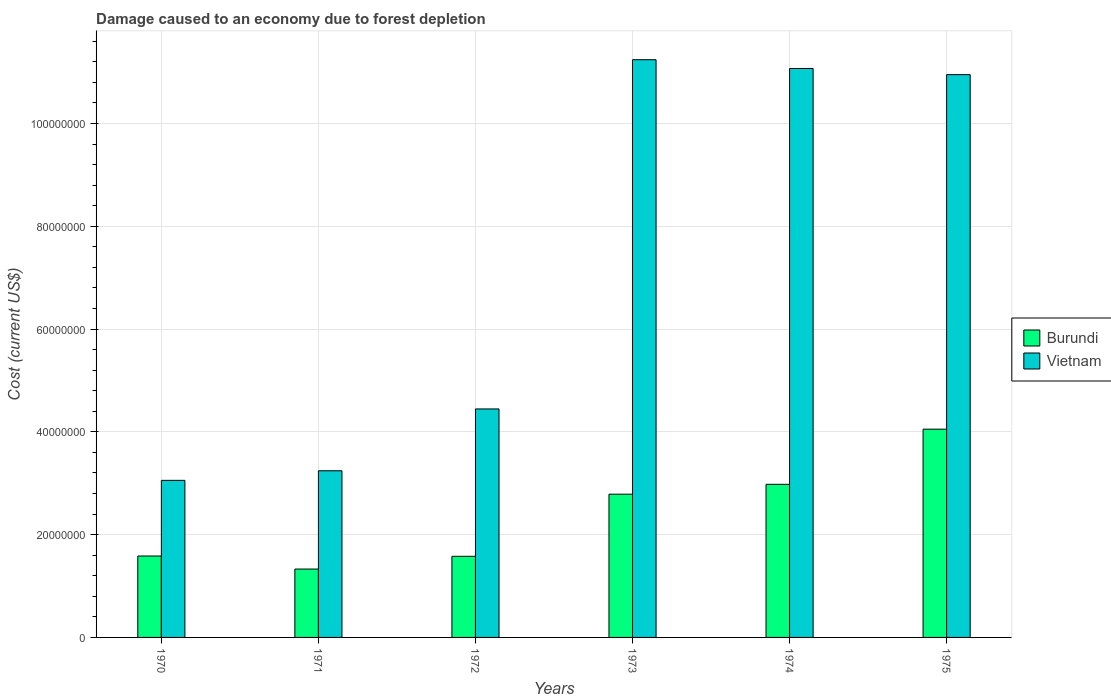How many groups of bars are there?
Provide a short and direct response. 6. Are the number of bars per tick equal to the number of legend labels?
Provide a short and direct response. Yes. How many bars are there on the 5th tick from the left?
Your answer should be compact. 2. What is the label of the 4th group of bars from the left?
Offer a terse response. 1973. What is the cost of damage caused due to forest depletion in Burundi in 1972?
Your answer should be very brief. 1.58e+07. Across all years, what is the maximum cost of damage caused due to forest depletion in Vietnam?
Your answer should be compact. 1.12e+08. Across all years, what is the minimum cost of damage caused due to forest depletion in Burundi?
Give a very brief answer. 1.33e+07. In which year was the cost of damage caused due to forest depletion in Burundi maximum?
Give a very brief answer. 1975. What is the total cost of damage caused due to forest depletion in Burundi in the graph?
Keep it short and to the point. 1.43e+08. What is the difference between the cost of damage caused due to forest depletion in Vietnam in 1970 and that in 1975?
Offer a terse response. -7.89e+07. What is the difference between the cost of damage caused due to forest depletion in Burundi in 1975 and the cost of damage caused due to forest depletion in Vietnam in 1972?
Your answer should be very brief. -3.94e+06. What is the average cost of damage caused due to forest depletion in Vietnam per year?
Your response must be concise. 7.33e+07. In the year 1970, what is the difference between the cost of damage caused due to forest depletion in Vietnam and cost of damage caused due to forest depletion in Burundi?
Offer a very short reply. 1.47e+07. In how many years, is the cost of damage caused due to forest depletion in Burundi greater than 52000000 US$?
Provide a short and direct response. 0. What is the ratio of the cost of damage caused due to forest depletion in Burundi in 1970 to that in 1975?
Your answer should be compact. 0.39. Is the cost of damage caused due to forest depletion in Vietnam in 1973 less than that in 1974?
Your response must be concise. No. What is the difference between the highest and the second highest cost of damage caused due to forest depletion in Burundi?
Provide a short and direct response. 1.07e+07. What is the difference between the highest and the lowest cost of damage caused due to forest depletion in Burundi?
Make the answer very short. 2.72e+07. Is the sum of the cost of damage caused due to forest depletion in Burundi in 1973 and 1974 greater than the maximum cost of damage caused due to forest depletion in Vietnam across all years?
Provide a short and direct response. No. What does the 2nd bar from the left in 1973 represents?
Provide a succinct answer. Vietnam. What does the 2nd bar from the right in 1972 represents?
Keep it short and to the point. Burundi. How many bars are there?
Your answer should be compact. 12. Are all the bars in the graph horizontal?
Provide a short and direct response. No. What is the difference between two consecutive major ticks on the Y-axis?
Provide a short and direct response. 2.00e+07. Does the graph contain any zero values?
Your response must be concise. No. How many legend labels are there?
Provide a succinct answer. 2. How are the legend labels stacked?
Ensure brevity in your answer.  Vertical. What is the title of the graph?
Ensure brevity in your answer.  Damage caused to an economy due to forest depletion. What is the label or title of the Y-axis?
Provide a short and direct response. Cost (current US$). What is the Cost (current US$) in Burundi in 1970?
Ensure brevity in your answer.  1.58e+07. What is the Cost (current US$) of Vietnam in 1970?
Offer a very short reply. 3.06e+07. What is the Cost (current US$) of Burundi in 1971?
Offer a terse response. 1.33e+07. What is the Cost (current US$) in Vietnam in 1971?
Ensure brevity in your answer.  3.24e+07. What is the Cost (current US$) of Burundi in 1972?
Offer a very short reply. 1.58e+07. What is the Cost (current US$) in Vietnam in 1972?
Give a very brief answer. 4.45e+07. What is the Cost (current US$) of Burundi in 1973?
Make the answer very short. 2.79e+07. What is the Cost (current US$) in Vietnam in 1973?
Your answer should be compact. 1.12e+08. What is the Cost (current US$) of Burundi in 1974?
Ensure brevity in your answer.  2.98e+07. What is the Cost (current US$) in Vietnam in 1974?
Your response must be concise. 1.11e+08. What is the Cost (current US$) in Burundi in 1975?
Your answer should be very brief. 4.05e+07. What is the Cost (current US$) in Vietnam in 1975?
Give a very brief answer. 1.10e+08. Across all years, what is the maximum Cost (current US$) in Burundi?
Your answer should be compact. 4.05e+07. Across all years, what is the maximum Cost (current US$) in Vietnam?
Your answer should be compact. 1.12e+08. Across all years, what is the minimum Cost (current US$) of Burundi?
Provide a succinct answer. 1.33e+07. Across all years, what is the minimum Cost (current US$) of Vietnam?
Provide a short and direct response. 3.06e+07. What is the total Cost (current US$) of Burundi in the graph?
Give a very brief answer. 1.43e+08. What is the total Cost (current US$) of Vietnam in the graph?
Make the answer very short. 4.40e+08. What is the difference between the Cost (current US$) in Burundi in 1970 and that in 1971?
Make the answer very short. 2.54e+06. What is the difference between the Cost (current US$) of Vietnam in 1970 and that in 1971?
Provide a succinct answer. -1.87e+06. What is the difference between the Cost (current US$) of Burundi in 1970 and that in 1972?
Make the answer very short. 5.64e+04. What is the difference between the Cost (current US$) of Vietnam in 1970 and that in 1972?
Offer a very short reply. -1.39e+07. What is the difference between the Cost (current US$) of Burundi in 1970 and that in 1973?
Provide a succinct answer. -1.20e+07. What is the difference between the Cost (current US$) in Vietnam in 1970 and that in 1973?
Ensure brevity in your answer.  -8.18e+07. What is the difference between the Cost (current US$) of Burundi in 1970 and that in 1974?
Provide a succinct answer. -1.39e+07. What is the difference between the Cost (current US$) in Vietnam in 1970 and that in 1974?
Keep it short and to the point. -8.01e+07. What is the difference between the Cost (current US$) of Burundi in 1970 and that in 1975?
Your response must be concise. -2.47e+07. What is the difference between the Cost (current US$) in Vietnam in 1970 and that in 1975?
Your answer should be compact. -7.89e+07. What is the difference between the Cost (current US$) in Burundi in 1971 and that in 1972?
Ensure brevity in your answer.  -2.48e+06. What is the difference between the Cost (current US$) of Vietnam in 1971 and that in 1972?
Your answer should be compact. -1.20e+07. What is the difference between the Cost (current US$) of Burundi in 1971 and that in 1973?
Make the answer very short. -1.46e+07. What is the difference between the Cost (current US$) of Vietnam in 1971 and that in 1973?
Your answer should be compact. -8.00e+07. What is the difference between the Cost (current US$) of Burundi in 1971 and that in 1974?
Offer a very short reply. -1.65e+07. What is the difference between the Cost (current US$) in Vietnam in 1971 and that in 1974?
Your answer should be compact. -7.83e+07. What is the difference between the Cost (current US$) in Burundi in 1971 and that in 1975?
Keep it short and to the point. -2.72e+07. What is the difference between the Cost (current US$) of Vietnam in 1971 and that in 1975?
Offer a terse response. -7.71e+07. What is the difference between the Cost (current US$) of Burundi in 1972 and that in 1973?
Make the answer very short. -1.21e+07. What is the difference between the Cost (current US$) in Vietnam in 1972 and that in 1973?
Make the answer very short. -6.79e+07. What is the difference between the Cost (current US$) in Burundi in 1972 and that in 1974?
Offer a very short reply. -1.40e+07. What is the difference between the Cost (current US$) of Vietnam in 1972 and that in 1974?
Give a very brief answer. -6.62e+07. What is the difference between the Cost (current US$) in Burundi in 1972 and that in 1975?
Make the answer very short. -2.47e+07. What is the difference between the Cost (current US$) in Vietnam in 1972 and that in 1975?
Keep it short and to the point. -6.50e+07. What is the difference between the Cost (current US$) of Burundi in 1973 and that in 1974?
Ensure brevity in your answer.  -1.92e+06. What is the difference between the Cost (current US$) in Vietnam in 1973 and that in 1974?
Make the answer very short. 1.70e+06. What is the difference between the Cost (current US$) in Burundi in 1973 and that in 1975?
Your answer should be compact. -1.27e+07. What is the difference between the Cost (current US$) of Vietnam in 1973 and that in 1975?
Your answer should be very brief. 2.90e+06. What is the difference between the Cost (current US$) of Burundi in 1974 and that in 1975?
Provide a succinct answer. -1.07e+07. What is the difference between the Cost (current US$) in Vietnam in 1974 and that in 1975?
Your response must be concise. 1.20e+06. What is the difference between the Cost (current US$) of Burundi in 1970 and the Cost (current US$) of Vietnam in 1971?
Ensure brevity in your answer.  -1.66e+07. What is the difference between the Cost (current US$) of Burundi in 1970 and the Cost (current US$) of Vietnam in 1972?
Give a very brief answer. -2.86e+07. What is the difference between the Cost (current US$) in Burundi in 1970 and the Cost (current US$) in Vietnam in 1973?
Provide a succinct answer. -9.66e+07. What is the difference between the Cost (current US$) in Burundi in 1970 and the Cost (current US$) in Vietnam in 1974?
Keep it short and to the point. -9.49e+07. What is the difference between the Cost (current US$) in Burundi in 1970 and the Cost (current US$) in Vietnam in 1975?
Your answer should be very brief. -9.37e+07. What is the difference between the Cost (current US$) in Burundi in 1971 and the Cost (current US$) in Vietnam in 1972?
Provide a succinct answer. -3.12e+07. What is the difference between the Cost (current US$) in Burundi in 1971 and the Cost (current US$) in Vietnam in 1973?
Provide a succinct answer. -9.91e+07. What is the difference between the Cost (current US$) of Burundi in 1971 and the Cost (current US$) of Vietnam in 1974?
Offer a very short reply. -9.74e+07. What is the difference between the Cost (current US$) of Burundi in 1971 and the Cost (current US$) of Vietnam in 1975?
Keep it short and to the point. -9.62e+07. What is the difference between the Cost (current US$) of Burundi in 1972 and the Cost (current US$) of Vietnam in 1973?
Offer a terse response. -9.66e+07. What is the difference between the Cost (current US$) in Burundi in 1972 and the Cost (current US$) in Vietnam in 1974?
Provide a succinct answer. -9.49e+07. What is the difference between the Cost (current US$) in Burundi in 1972 and the Cost (current US$) in Vietnam in 1975?
Your answer should be compact. -9.37e+07. What is the difference between the Cost (current US$) of Burundi in 1973 and the Cost (current US$) of Vietnam in 1974?
Make the answer very short. -8.28e+07. What is the difference between the Cost (current US$) in Burundi in 1973 and the Cost (current US$) in Vietnam in 1975?
Offer a very short reply. -8.16e+07. What is the difference between the Cost (current US$) in Burundi in 1974 and the Cost (current US$) in Vietnam in 1975?
Ensure brevity in your answer.  -7.97e+07. What is the average Cost (current US$) of Burundi per year?
Keep it short and to the point. 2.39e+07. What is the average Cost (current US$) of Vietnam per year?
Offer a very short reply. 7.33e+07. In the year 1970, what is the difference between the Cost (current US$) in Burundi and Cost (current US$) in Vietnam?
Ensure brevity in your answer.  -1.47e+07. In the year 1971, what is the difference between the Cost (current US$) of Burundi and Cost (current US$) of Vietnam?
Provide a succinct answer. -1.91e+07. In the year 1972, what is the difference between the Cost (current US$) of Burundi and Cost (current US$) of Vietnam?
Provide a succinct answer. -2.87e+07. In the year 1973, what is the difference between the Cost (current US$) in Burundi and Cost (current US$) in Vietnam?
Ensure brevity in your answer.  -8.45e+07. In the year 1974, what is the difference between the Cost (current US$) in Burundi and Cost (current US$) in Vietnam?
Provide a short and direct response. -8.09e+07. In the year 1975, what is the difference between the Cost (current US$) of Burundi and Cost (current US$) of Vietnam?
Offer a terse response. -6.90e+07. What is the ratio of the Cost (current US$) of Burundi in 1970 to that in 1971?
Your answer should be very brief. 1.19. What is the ratio of the Cost (current US$) of Vietnam in 1970 to that in 1971?
Make the answer very short. 0.94. What is the ratio of the Cost (current US$) in Vietnam in 1970 to that in 1972?
Give a very brief answer. 0.69. What is the ratio of the Cost (current US$) of Burundi in 1970 to that in 1973?
Offer a very short reply. 0.57. What is the ratio of the Cost (current US$) in Vietnam in 1970 to that in 1973?
Your response must be concise. 0.27. What is the ratio of the Cost (current US$) of Burundi in 1970 to that in 1974?
Your response must be concise. 0.53. What is the ratio of the Cost (current US$) of Vietnam in 1970 to that in 1974?
Your response must be concise. 0.28. What is the ratio of the Cost (current US$) in Burundi in 1970 to that in 1975?
Your answer should be compact. 0.39. What is the ratio of the Cost (current US$) of Vietnam in 1970 to that in 1975?
Provide a succinct answer. 0.28. What is the ratio of the Cost (current US$) in Burundi in 1971 to that in 1972?
Ensure brevity in your answer.  0.84. What is the ratio of the Cost (current US$) of Vietnam in 1971 to that in 1972?
Ensure brevity in your answer.  0.73. What is the ratio of the Cost (current US$) in Burundi in 1971 to that in 1973?
Ensure brevity in your answer.  0.48. What is the ratio of the Cost (current US$) in Vietnam in 1971 to that in 1973?
Your response must be concise. 0.29. What is the ratio of the Cost (current US$) in Burundi in 1971 to that in 1974?
Offer a very short reply. 0.45. What is the ratio of the Cost (current US$) in Vietnam in 1971 to that in 1974?
Your answer should be compact. 0.29. What is the ratio of the Cost (current US$) of Burundi in 1971 to that in 1975?
Your response must be concise. 0.33. What is the ratio of the Cost (current US$) in Vietnam in 1971 to that in 1975?
Offer a very short reply. 0.3. What is the ratio of the Cost (current US$) in Burundi in 1972 to that in 1973?
Offer a terse response. 0.57. What is the ratio of the Cost (current US$) in Vietnam in 1972 to that in 1973?
Keep it short and to the point. 0.4. What is the ratio of the Cost (current US$) in Burundi in 1972 to that in 1974?
Keep it short and to the point. 0.53. What is the ratio of the Cost (current US$) of Vietnam in 1972 to that in 1974?
Provide a succinct answer. 0.4. What is the ratio of the Cost (current US$) in Burundi in 1972 to that in 1975?
Offer a terse response. 0.39. What is the ratio of the Cost (current US$) of Vietnam in 1972 to that in 1975?
Keep it short and to the point. 0.41. What is the ratio of the Cost (current US$) of Burundi in 1973 to that in 1974?
Your answer should be compact. 0.94. What is the ratio of the Cost (current US$) in Vietnam in 1973 to that in 1974?
Provide a succinct answer. 1.02. What is the ratio of the Cost (current US$) in Burundi in 1973 to that in 1975?
Make the answer very short. 0.69. What is the ratio of the Cost (current US$) of Vietnam in 1973 to that in 1975?
Give a very brief answer. 1.03. What is the ratio of the Cost (current US$) of Burundi in 1974 to that in 1975?
Your answer should be very brief. 0.74. What is the ratio of the Cost (current US$) of Vietnam in 1974 to that in 1975?
Provide a short and direct response. 1.01. What is the difference between the highest and the second highest Cost (current US$) in Burundi?
Your answer should be compact. 1.07e+07. What is the difference between the highest and the second highest Cost (current US$) in Vietnam?
Keep it short and to the point. 1.70e+06. What is the difference between the highest and the lowest Cost (current US$) of Burundi?
Make the answer very short. 2.72e+07. What is the difference between the highest and the lowest Cost (current US$) of Vietnam?
Your answer should be very brief. 8.18e+07. 